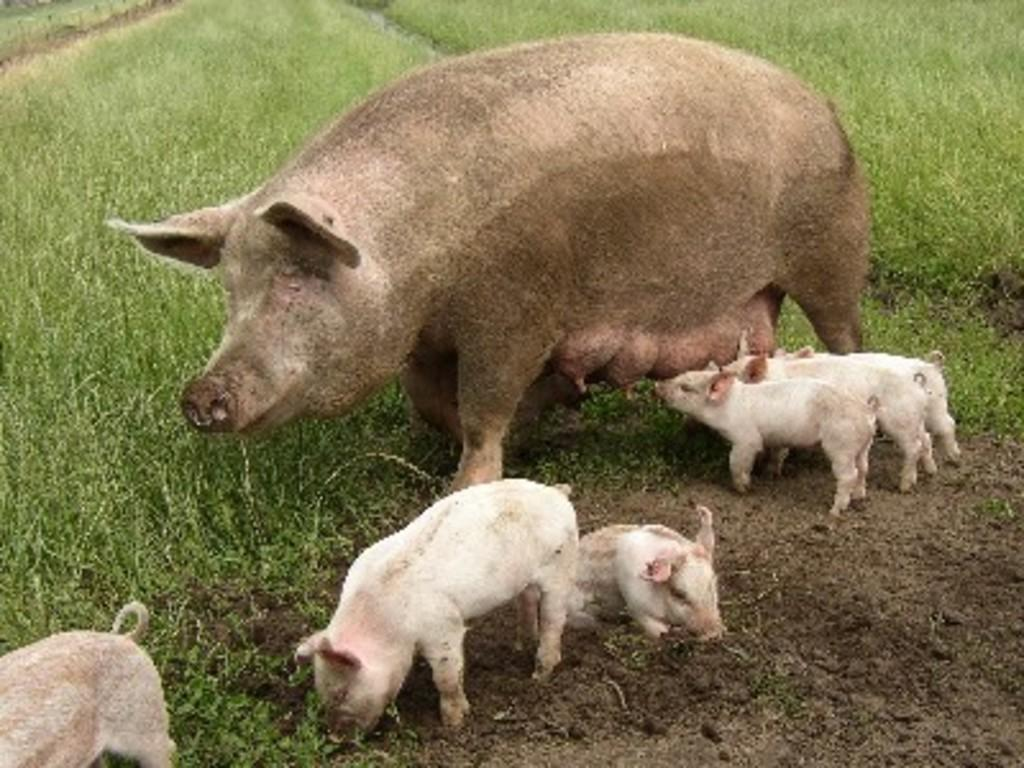What type of animal is in the image? There is a pig in the image. Are there any other animals in the image? Yes, there are piglets in the image. What can be seen in the background of the image? There is grass in the background of the image. What type of suit is the boy wearing in the image? There is no boy or suit present in the image; it features a pig and piglets in a grassy background. 